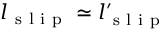Convert formula to latex. <formula><loc_0><loc_0><loc_500><loc_500>l _ { s l i p } \simeq l _ { s l i p } ^ { \prime }</formula> 